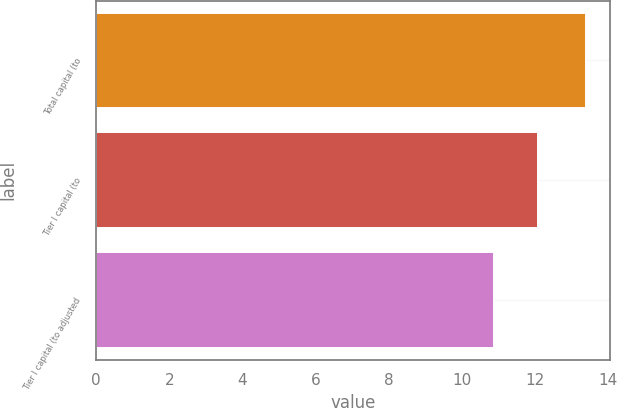Convert chart to OTSL. <chart><loc_0><loc_0><loc_500><loc_500><bar_chart><fcel>Total capital (to<fcel>Tier I capital (to<fcel>Tier I capital (to adjusted<nl><fcel>13.4<fcel>12.1<fcel>10.9<nl></chart> 